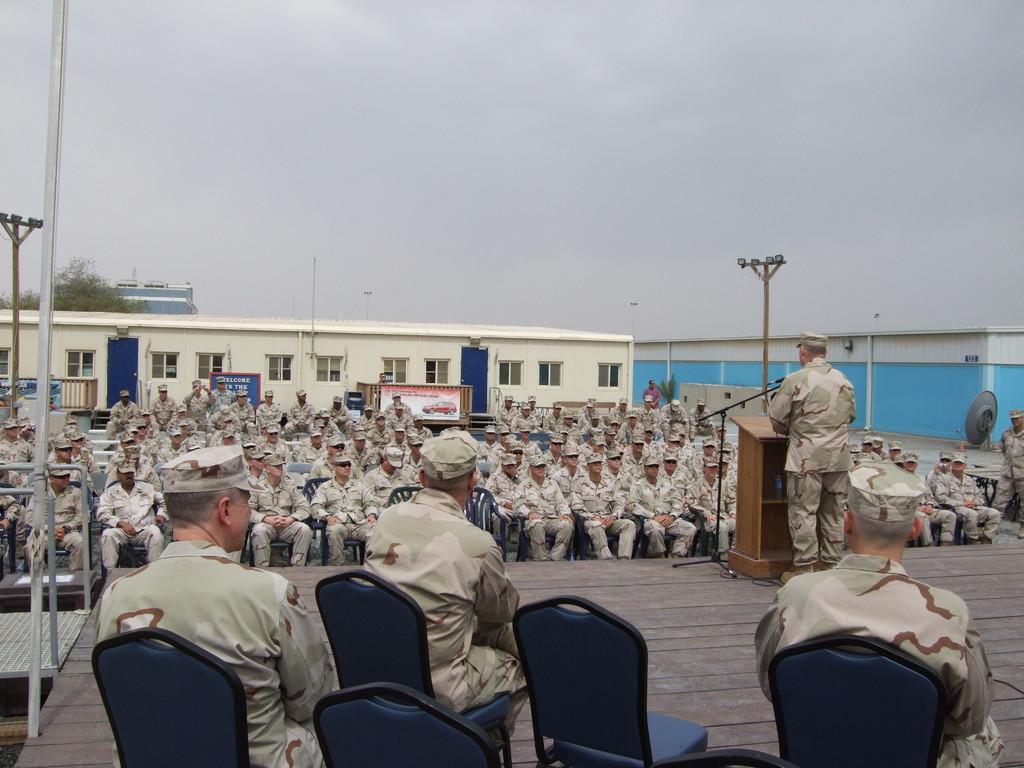Could you give a brief overview of what you see in this image? Here we can see a group soldiers who are sitting on a chair and paying attention to this person. This person standing in front of a wooden desk and he is speaking on a microphone. Here we can see a tree, a house and an electric pole. 